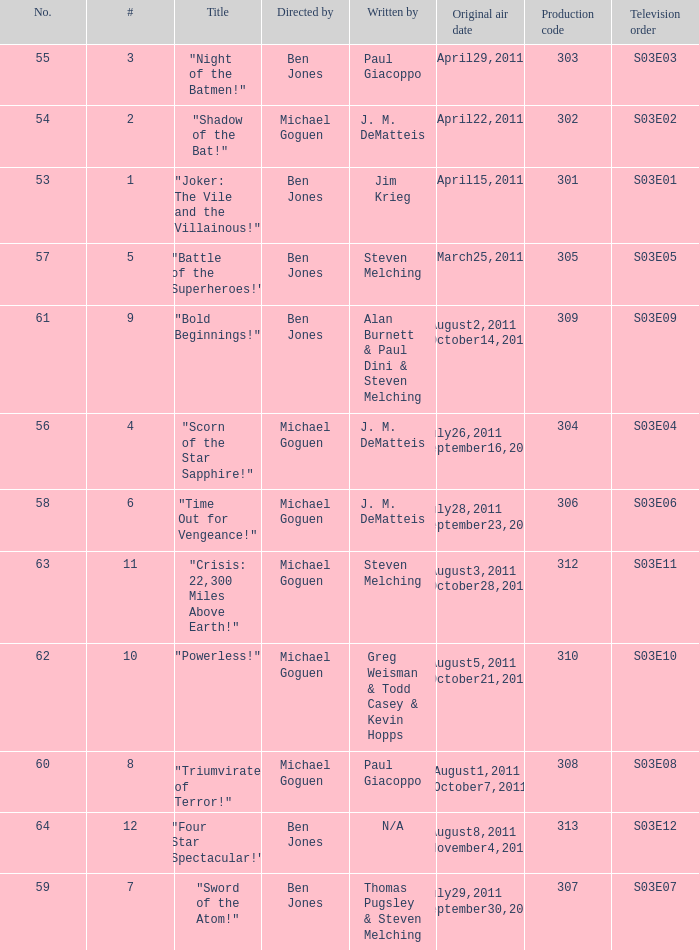Help me parse the entirety of this table. {'header': ['No.', '#', 'Title', 'Directed by', 'Written by', 'Original air date', 'Production code', 'Television order'], 'rows': [['55', '3', '"Night of the Batmen!"', 'Ben Jones', 'Paul Giacoppo', 'April29,2011', '303', 'S03E03'], ['54', '2', '"Shadow of the Bat!"', 'Michael Goguen', 'J. M. DeMatteis', 'April22,2011', '302', 'S03E02'], ['53', '1', '"Joker: The Vile and the Villainous!"', 'Ben Jones', 'Jim Krieg', 'April15,2011', '301', 'S03E01'], ['57', '5', '"Battle of the Superheroes!"', 'Ben Jones', 'Steven Melching', 'March25,2011', '305', 'S03E05'], ['61', '9', '"Bold Beginnings!"', 'Ben Jones', 'Alan Burnett & Paul Dini & Steven Melching', 'August2,2011 October14,2011', '309', 'S03E09'], ['56', '4', '"Scorn of the Star Sapphire!"', 'Michael Goguen', 'J. M. DeMatteis', 'July26,2011 September16,2011', '304', 'S03E04'], ['58', '6', '"Time Out for Vengeance!"', 'Michael Goguen', 'J. M. DeMatteis', 'July28,2011 September23,2011', '306', 'S03E06'], ['63', '11', '"Crisis: 22,300 Miles Above Earth!"', 'Michael Goguen', 'Steven Melching', 'August3,2011 October28,2011', '312', 'S03E11'], ['62', '10', '"Powerless!"', 'Michael Goguen', 'Greg Weisman & Todd Casey & Kevin Hopps', 'August5,2011 October21,2011', '310', 'S03E10'], ['60', '8', '"Triumvirate of Terror!"', 'Michael Goguen', 'Paul Giacoppo', 'August1,2011 October7,2011', '308', 'S03E08'], ['64', '12', '"Four Star Spectacular!"', 'Ben Jones', 'N/A', 'August8,2011 November4,2011', '313', 'S03E12'], ['59', '7', '"Sword of the Atom!"', 'Ben Jones', 'Thomas Pugsley & Steven Melching', 'July29,2011 September30,2011', '307', 'S03E07']]} What was the original air date for "Crisis: 22,300 Miles Above Earth!"? August3,2011 October28,2011. 